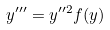<formula> <loc_0><loc_0><loc_500><loc_500>y ^ { \prime \prime \prime } = y ^ { \prime \prime 2 } f ( y )</formula> 